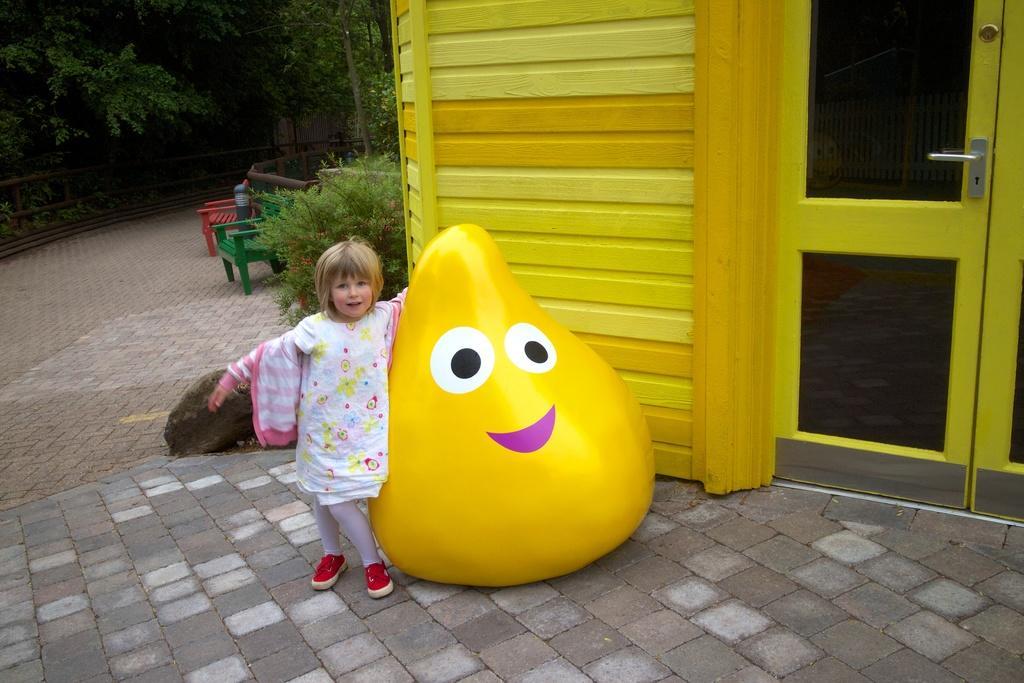Describe this image in one or two sentences. In this image we can see there is a little girl standing beside the toy. On the right side of the image there is a house. In the background there are trees. 